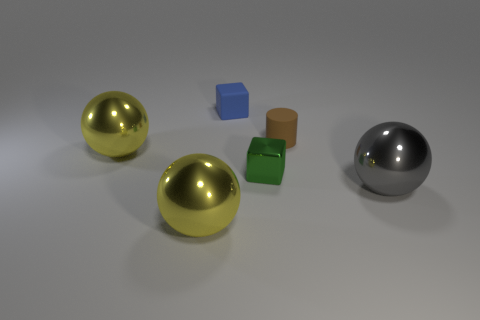Subtract all yellow metallic spheres. How many spheres are left? 1 Add 4 brown rubber things. How many objects exist? 10 Subtract all blue blocks. How many blocks are left? 1 Subtract all tiny blue things. Subtract all green things. How many objects are left? 4 Add 6 brown objects. How many brown objects are left? 7 Add 2 blocks. How many blocks exist? 4 Subtract 0 cyan cylinders. How many objects are left? 6 Subtract all cylinders. How many objects are left? 5 Subtract 1 cylinders. How many cylinders are left? 0 Subtract all yellow cylinders. Subtract all blue balls. How many cylinders are left? 1 